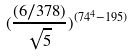Convert formula to latex. <formula><loc_0><loc_0><loc_500><loc_500>( \frac { ( 6 / 3 7 8 ) } { \sqrt { 5 } } ) ^ { ( 7 4 ^ { 4 } - 1 9 5 ) }</formula> 